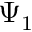<formula> <loc_0><loc_0><loc_500><loc_500>\Psi _ { 1 }</formula> 